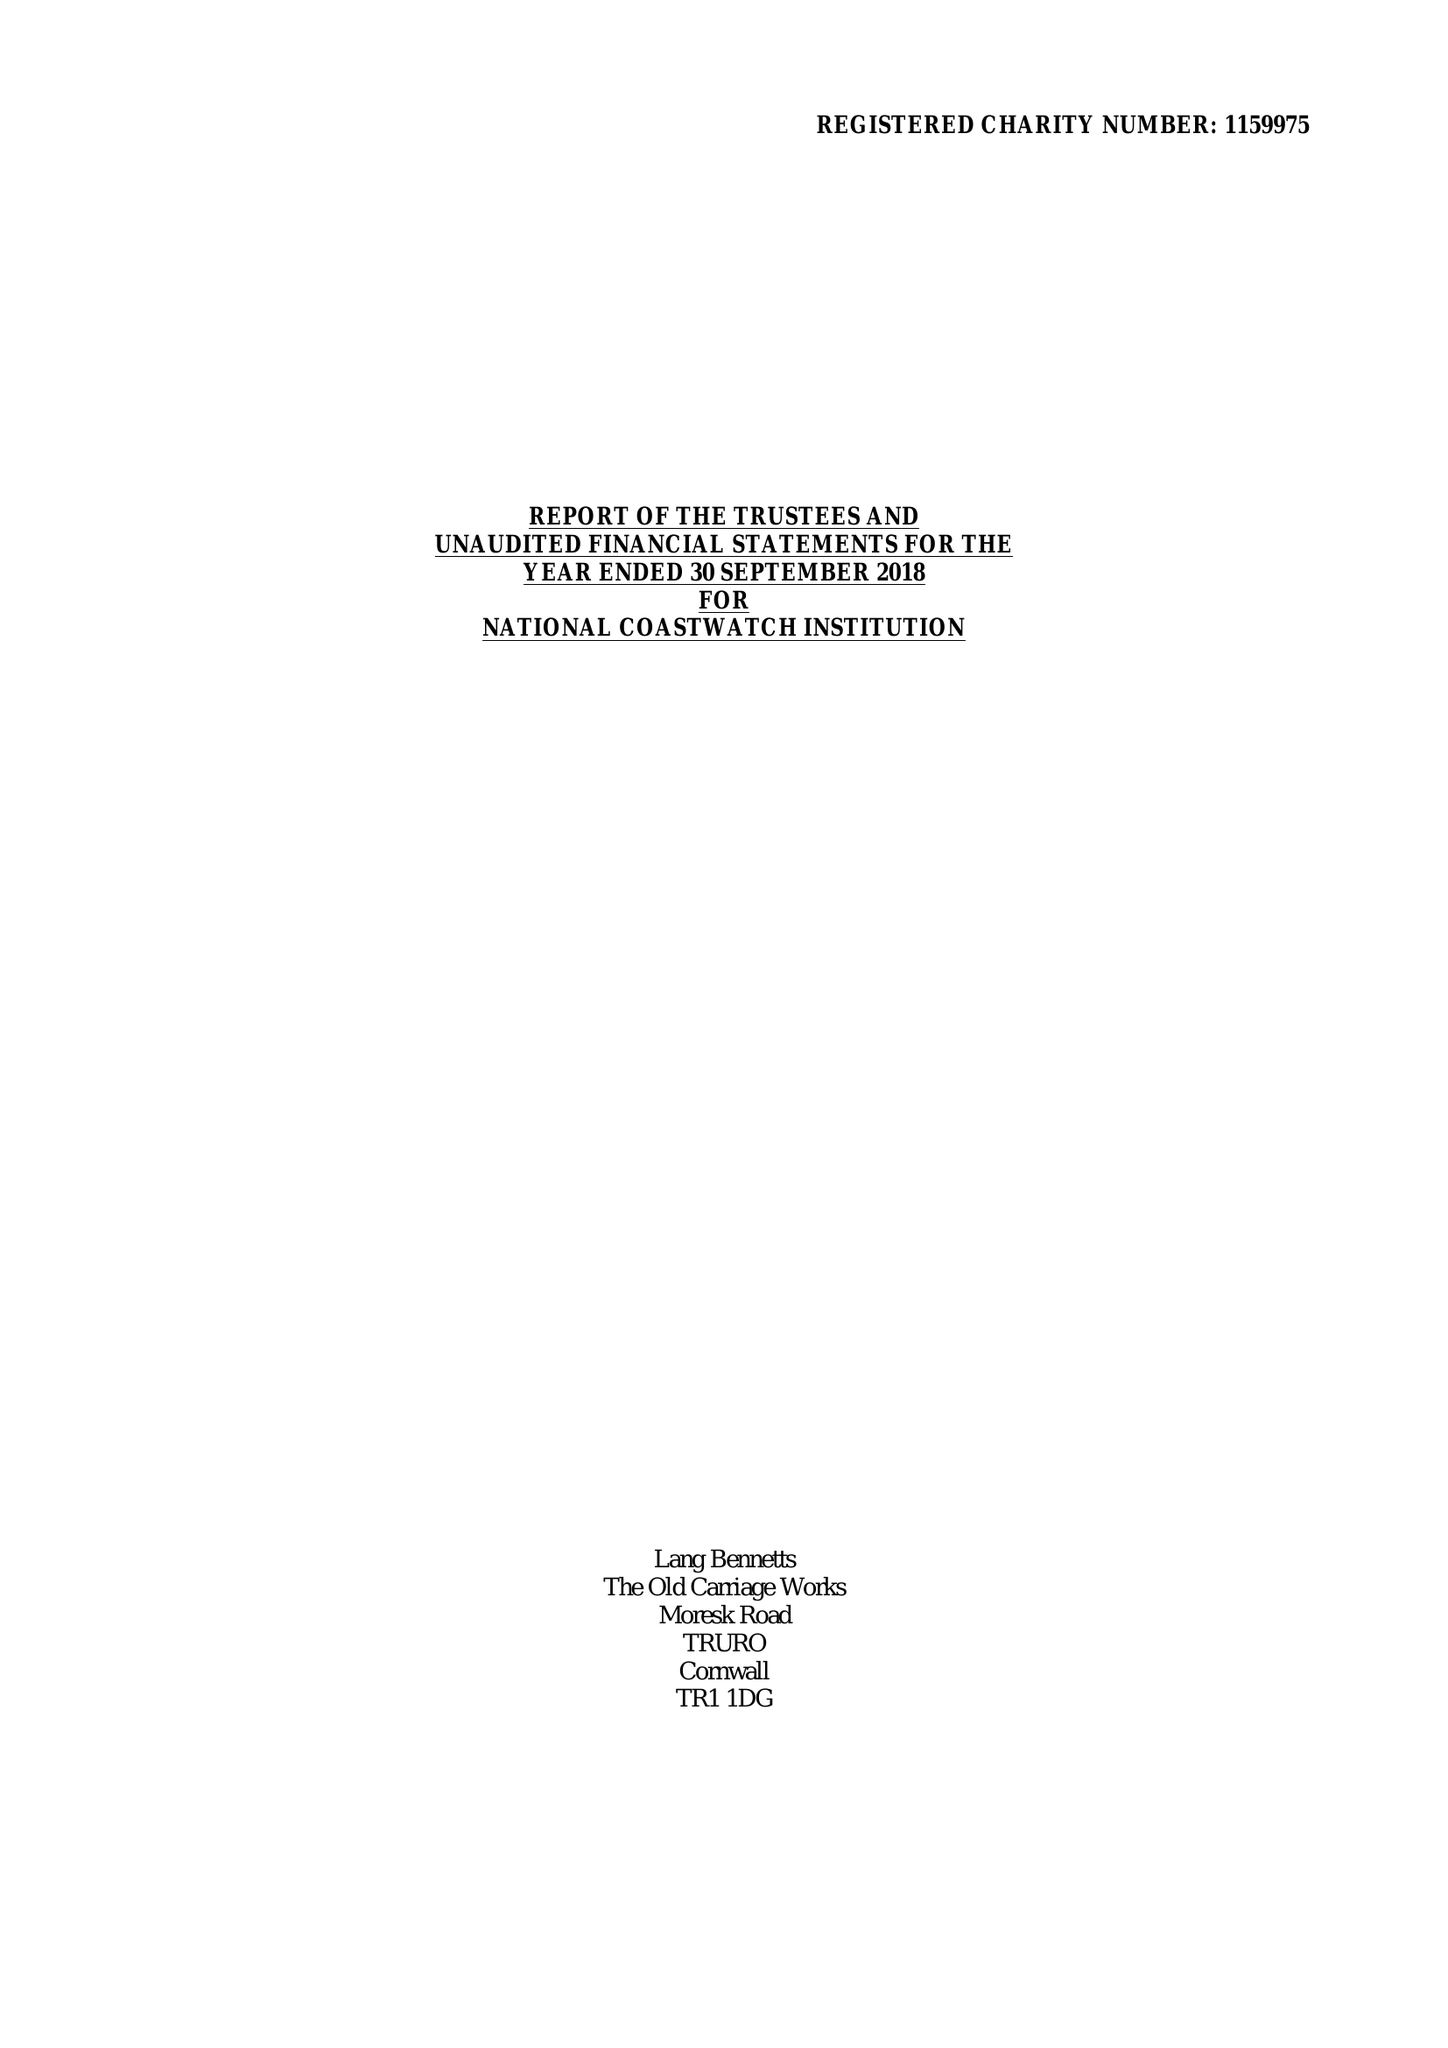What is the value for the income_annually_in_british_pounds?
Answer the question using a single word or phrase. 531194.00 